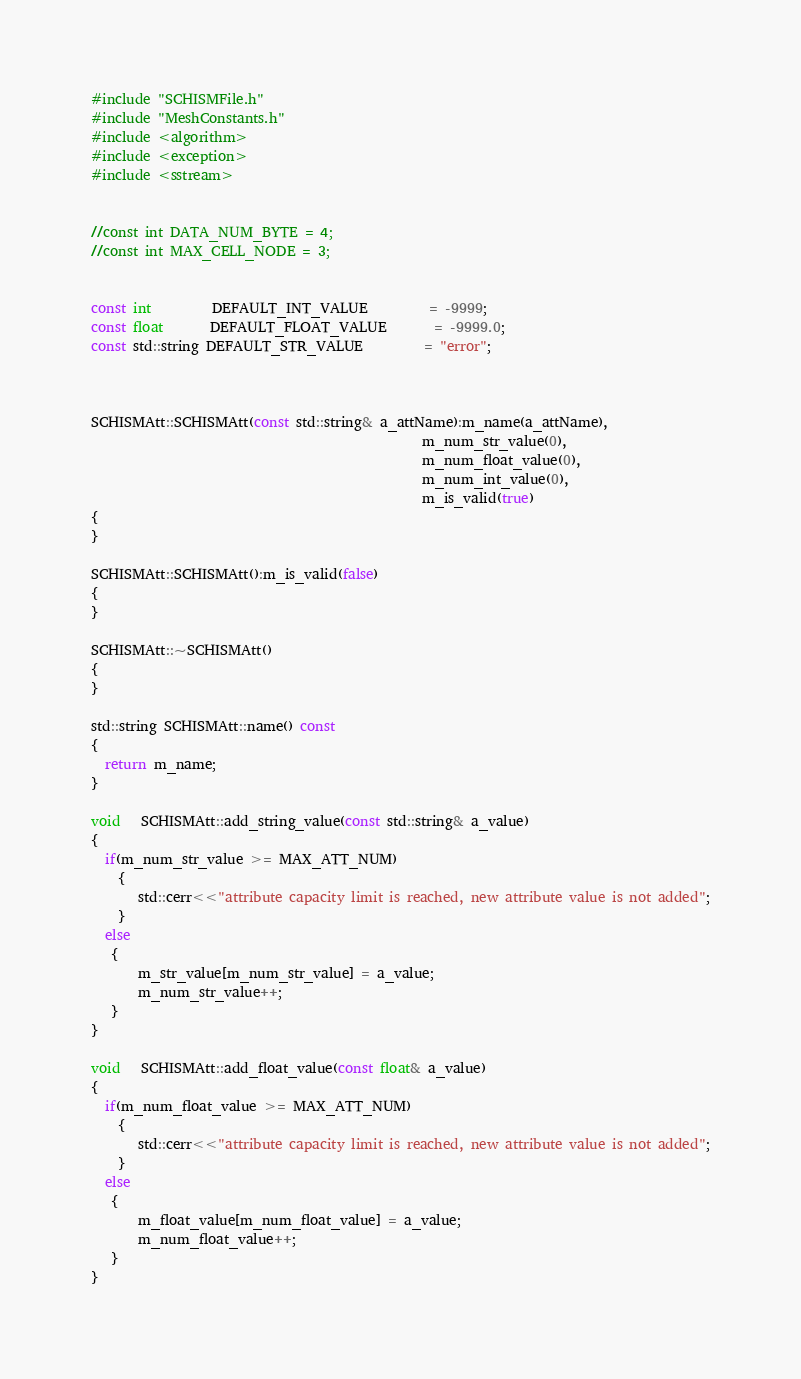<code> <loc_0><loc_0><loc_500><loc_500><_C++_>#include "SCHISMFile.h"
#include "MeshConstants.h"
#include <algorithm> 
#include <exception>
#include <sstream>


//const int DATA_NUM_BYTE = 4;
//const int MAX_CELL_NODE = 3;


const int         DEFAULT_INT_VALUE         = -9999;
const float       DEFAULT_FLOAT_VALUE       = -9999.0;
const std::string DEFAULT_STR_VALUE         = "error";



SCHISMAtt::SCHISMAtt(const std::string& a_attName):m_name(a_attName),
                                                 m_num_str_value(0),
                                                 m_num_float_value(0),
                                                 m_num_int_value(0),
                                                 m_is_valid(true)
{
}

SCHISMAtt::SCHISMAtt():m_is_valid(false)
{
}

SCHISMAtt::~SCHISMAtt()
{
}

std::string SCHISMAtt::name() const
{
  return m_name;
}

void   SCHISMAtt::add_string_value(const std::string& a_value)
{
  if(m_num_str_value >= MAX_ATT_NUM)
    {
       std::cerr<<"attribute capacity limit is reached, new attribute value is not added";
    }
  else
   {
       m_str_value[m_num_str_value] = a_value;
       m_num_str_value++;
   }
}

void   SCHISMAtt::add_float_value(const float& a_value)
{
  if(m_num_float_value >= MAX_ATT_NUM)
    {
       std::cerr<<"attribute capacity limit is reached, new attribute value is not added";
    }
  else
   {
       m_float_value[m_num_float_value] = a_value;
       m_num_float_value++;
   }
}
</code> 